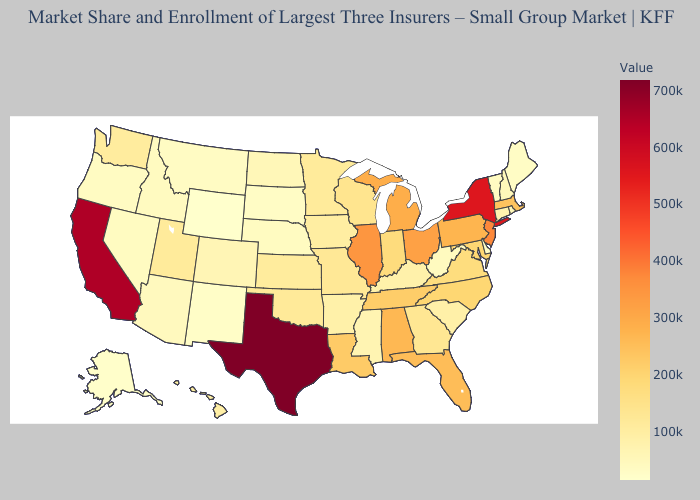Does Vermont have the lowest value in the Northeast?
Be succinct. No. Which states have the lowest value in the MidWest?
Quick response, please. South Dakota. Does Washington have the lowest value in the West?
Short answer required. No. Among the states that border New York , which have the lowest value?
Concise answer only. Vermont. Among the states that border Utah , does Colorado have the highest value?
Keep it brief. Yes. Among the states that border California , which have the lowest value?
Quick response, please. Oregon. 